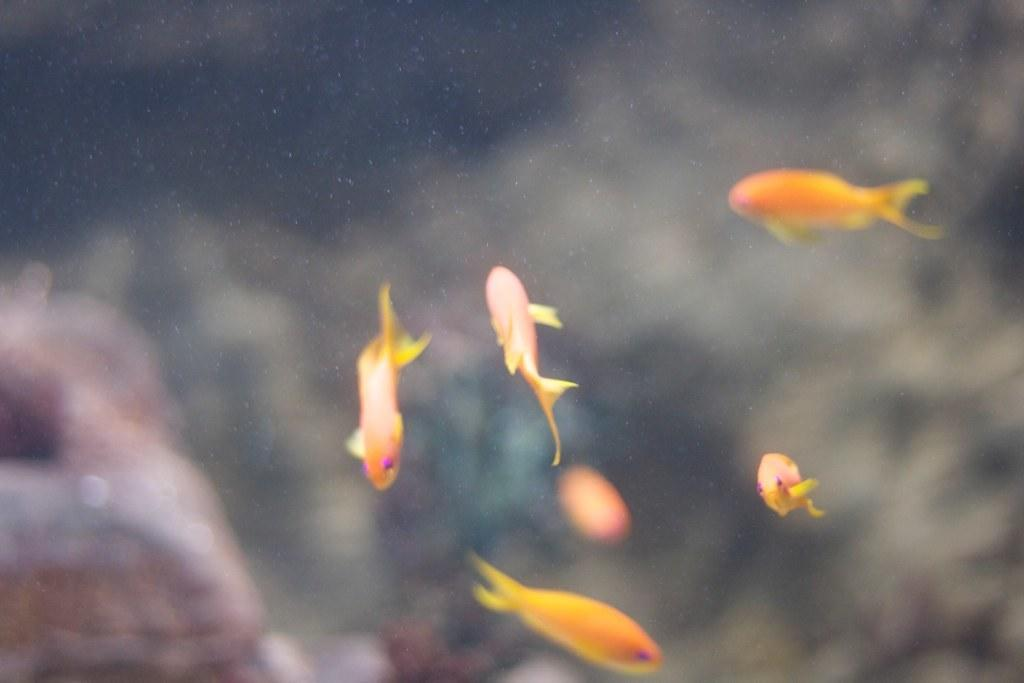What type of animals can be seen in the image? There are fishes in the image. Can you describe the appearance of the fishes? The fishes are in different colors. Where are the fishes located in the image? The fishes are in the water. How would you describe the background of the image? The background of the image is blurred. What type of insect is crawling on the actor's face in the image? There is no actor or insect present in the image; it features fishes in the water with a blurred background. 